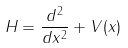<formula> <loc_0><loc_0><loc_500><loc_500>H = \frac { d ^ { 2 } } { d x ^ { 2 } } + V ( x )</formula> 